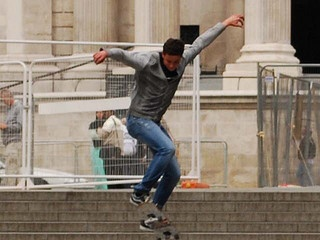Describe the objects in this image and their specific colors. I can see people in lightgray, black, gray, darkgray, and maroon tones and skateboard in lightgray, gray, and black tones in this image. 